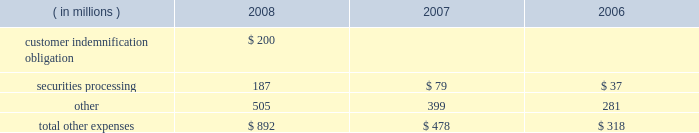Note 21 .
Expenses during the fourth quarter of 2008 , we elected to provide support to certain investment accounts managed by ssga through the purchase of asset- and mortgage-backed securities and a cash infusion , which resulted in a charge of $ 450 million .
Ssga manages certain investment accounts , offered to retirement plans , that allow participants to purchase and redeem units at a constant net asset value regardless of volatility in the underlying value of the assets held by the account .
The accounts enter into contractual arrangements with independent third-party financial institutions that agree to make up any shortfall in the account if all the units are redeemed at the constant net asset value .
The financial institutions have the right , under certain circumstances , to terminate this guarantee with respect to future investments in the account .
During 2008 , the liquidity and pricing issues in the fixed-income markets adversely affected the market value of the securities in these accounts to the point that the third-party guarantors considered terminating their financial guarantees with the accounts .
Although we were not statutorily or contractually obligated to do so , we elected to purchase approximately $ 2.49 billion of asset- and mortgage-backed securities from these accounts that had been identified as presenting increased risk in the current market environment and to contribute an aggregate of $ 450 million to the accounts to improve the ratio of the market value of the accounts 2019 portfolio holdings to the book value of the accounts .
We have no ongoing commitment or intent to provide support to these accounts .
The securities are carried in investment securities available for sale in our consolidated statement of condition .
The components of other expenses were as follows for the years ended december 31: .
In september and october 2008 , lehman brothers holdings inc. , or lehman brothers , and certain of its affiliates filed for bankruptcy or other insolvency proceedings .
While we had no unsecured financial exposure to lehman brothers or its affiliates , we indemnified certain customers in connection with these and other collateralized repurchase agreements with lehman brothers entities .
In the then current market environment , the market value of the underlying collateral had declined .
During the third quarter of 2008 , to the extent these declines resulted in collateral value falling below the indemnification obligation , we recorded a reserve to provide for our estimated net exposure .
The reserve , which totaled $ 200 million , was based on the cost of satisfying the indemnification obligation net of the fair value of the collateral , which we purchased during the fourth quarter of 2008 .
The collateral , composed of commercial real estate loans which are discussed in note 5 , is recorded in loans and leases in our consolidated statement of condition. .
What percent of 2008's total other expenses is the total customer indemnification reserve? 
Computations: (200 - 892)
Answer: -692.0. 